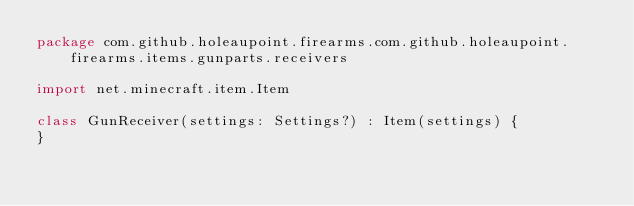Convert code to text. <code><loc_0><loc_0><loc_500><loc_500><_Kotlin_>package com.github.holeaupoint.firearms.com.github.holeaupoint.firearms.items.gunparts.receivers

import net.minecraft.item.Item

class GunReceiver(settings: Settings?) : Item(settings) {
}</code> 